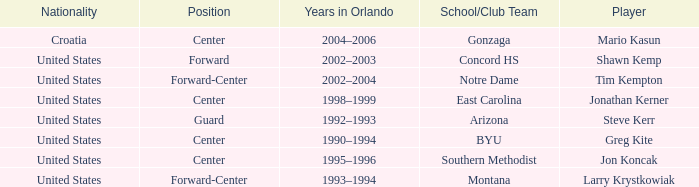Which player has montana as the school/club team? Larry Krystkowiak. 